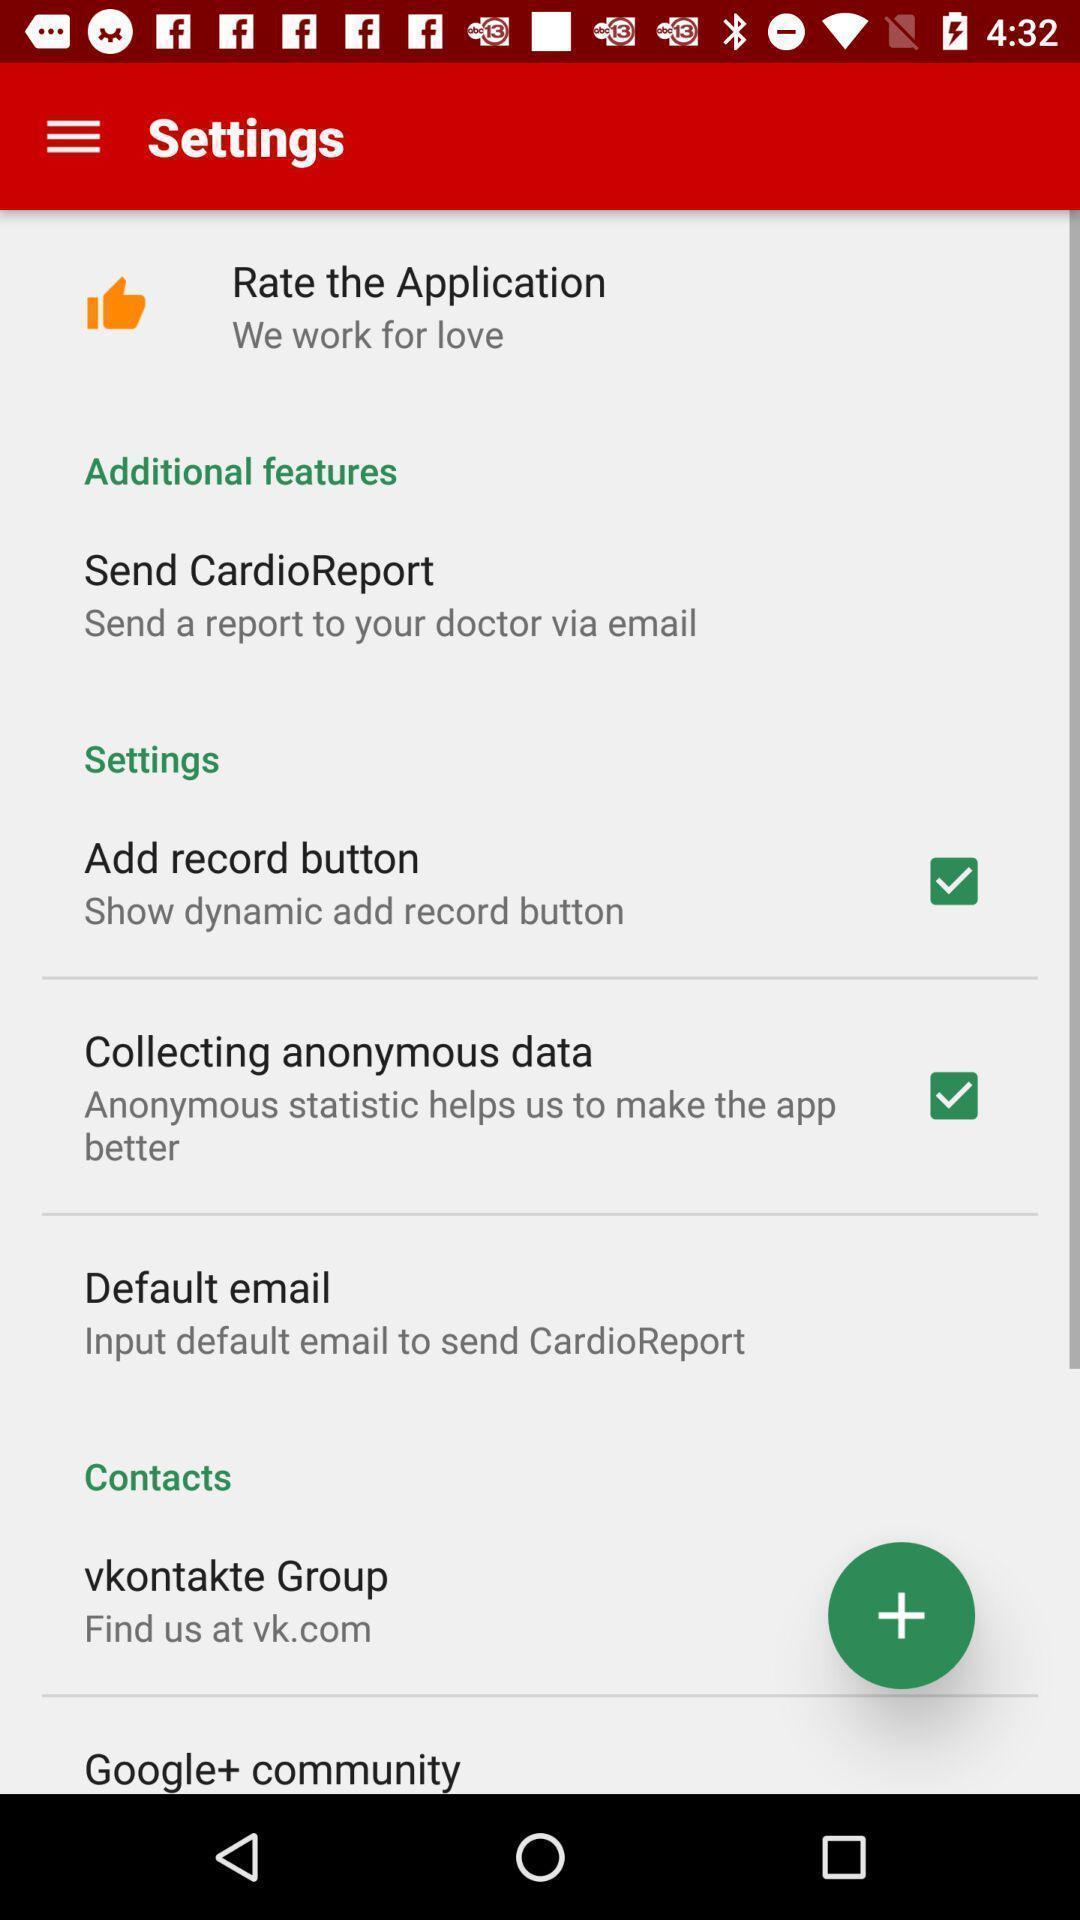Give me a summary of this screen capture. Settings page with various other options in an health application. 